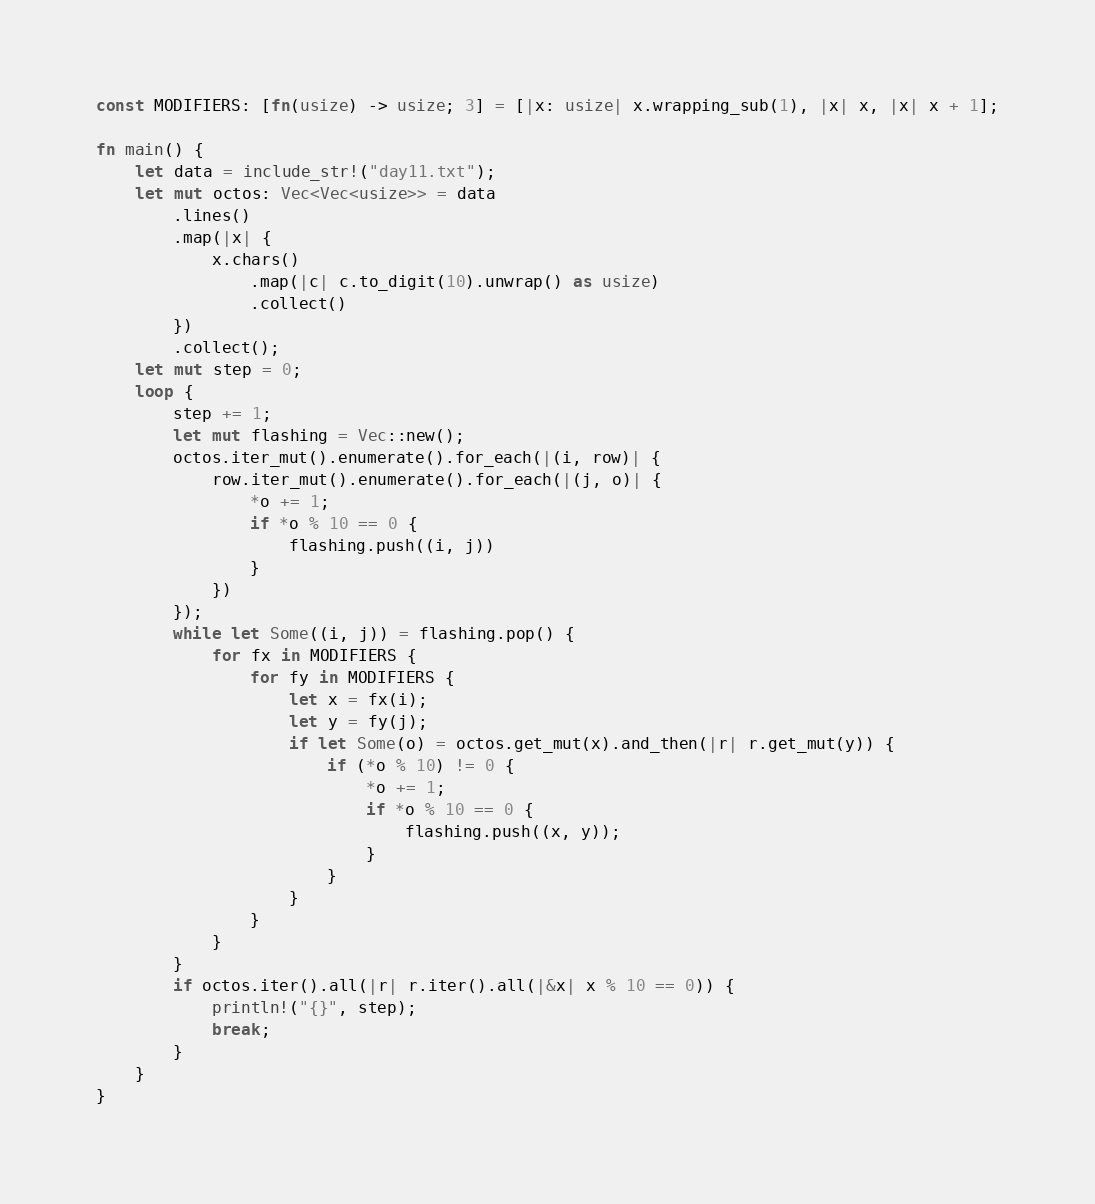Convert code to text. <code><loc_0><loc_0><loc_500><loc_500><_Rust_>const MODIFIERS: [fn(usize) -> usize; 3] = [|x: usize| x.wrapping_sub(1), |x| x, |x| x + 1];

fn main() {
    let data = include_str!("day11.txt");
    let mut octos: Vec<Vec<usize>> = data
        .lines()
        .map(|x| {
            x.chars()
                .map(|c| c.to_digit(10).unwrap() as usize)
                .collect()
        })
        .collect();
    let mut step = 0;
    loop {
        step += 1;
        let mut flashing = Vec::new();
        octos.iter_mut().enumerate().for_each(|(i, row)| {
            row.iter_mut().enumerate().for_each(|(j, o)| {
                *o += 1;
                if *o % 10 == 0 {
                    flashing.push((i, j))
                }
            })
        });
        while let Some((i, j)) = flashing.pop() {
            for fx in MODIFIERS {
                for fy in MODIFIERS {
                    let x = fx(i);
                    let y = fy(j);
                    if let Some(o) = octos.get_mut(x).and_then(|r| r.get_mut(y)) {
                        if (*o % 10) != 0 {
                            *o += 1;
                            if *o % 10 == 0 {
                                flashing.push((x, y));
                            }
                        }
                    }
                }
            }
        }
        if octos.iter().all(|r| r.iter().all(|&x| x % 10 == 0)) {
            println!("{}", step);
            break;
        }
    }
}
</code> 